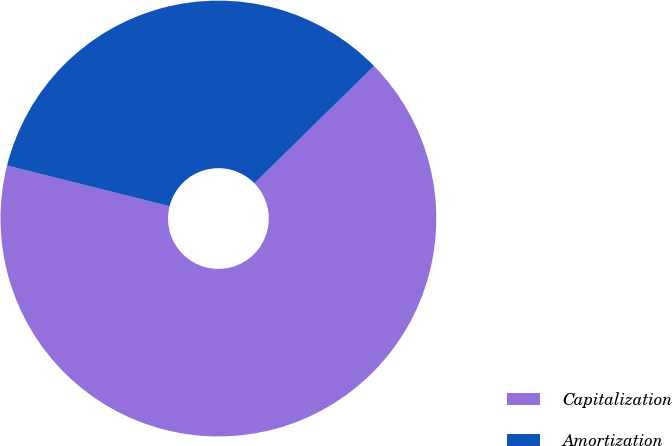Convert chart. <chart><loc_0><loc_0><loc_500><loc_500><pie_chart><fcel>Capitalization<fcel>Amortization<nl><fcel>66.24%<fcel>33.76%<nl></chart> 